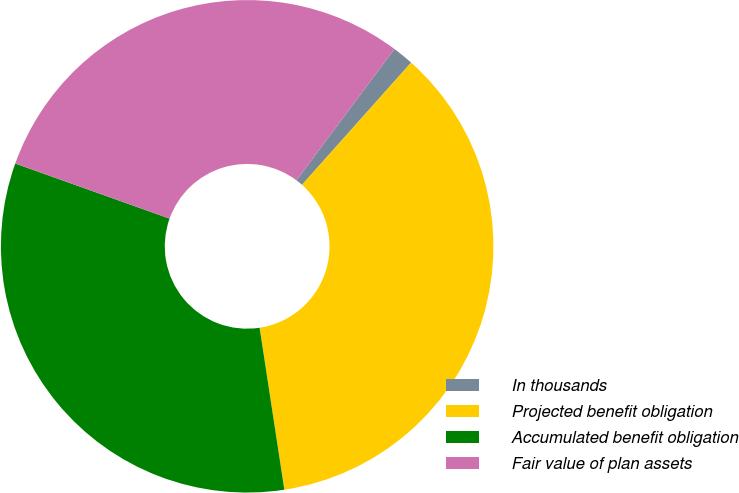Convert chart to OTSL. <chart><loc_0><loc_0><loc_500><loc_500><pie_chart><fcel>In thousands<fcel>Projected benefit obligation<fcel>Accumulated benefit obligation<fcel>Fair value of plan assets<nl><fcel>1.39%<fcel>35.99%<fcel>32.87%<fcel>29.75%<nl></chart> 